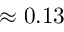<formula> <loc_0><loc_0><loc_500><loc_500>\approx 0 . 1 3</formula> 